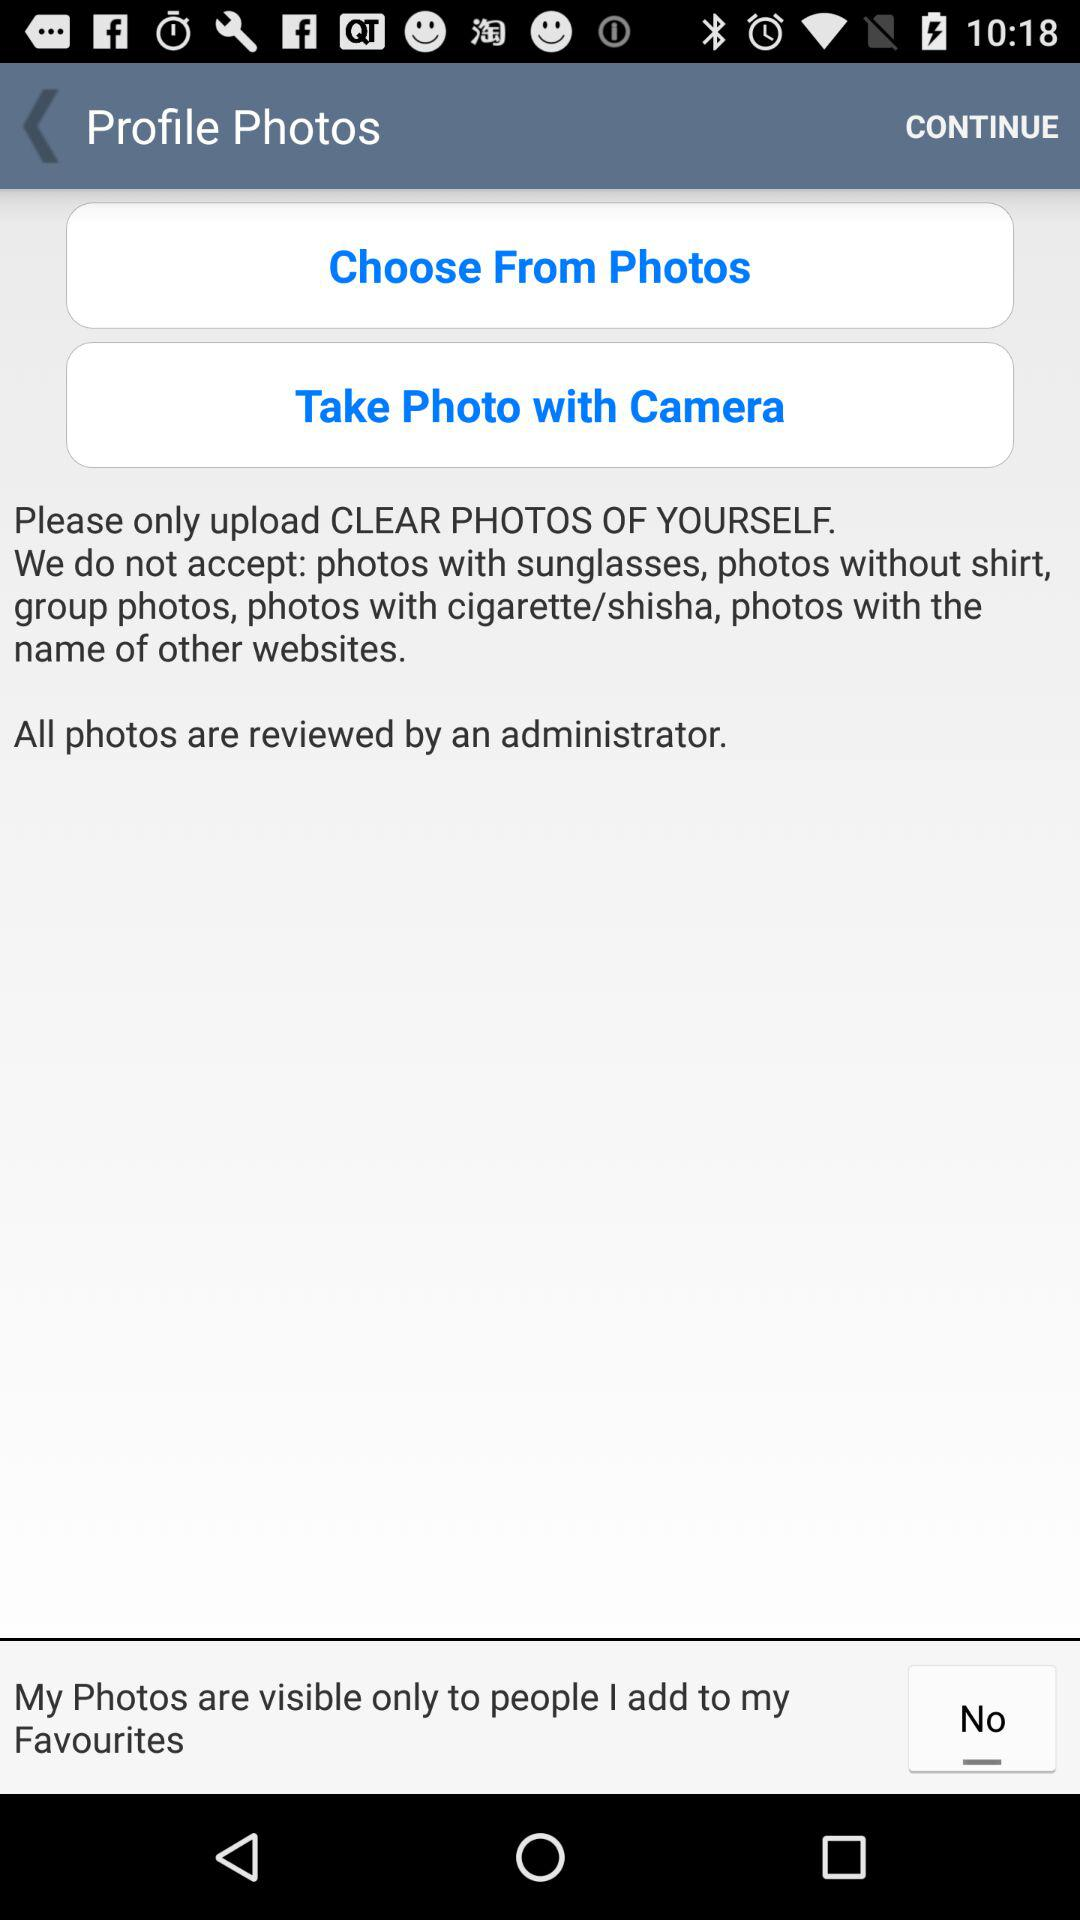To whom are my photos visible? Your photos are visible only to people you add to your favourites. 